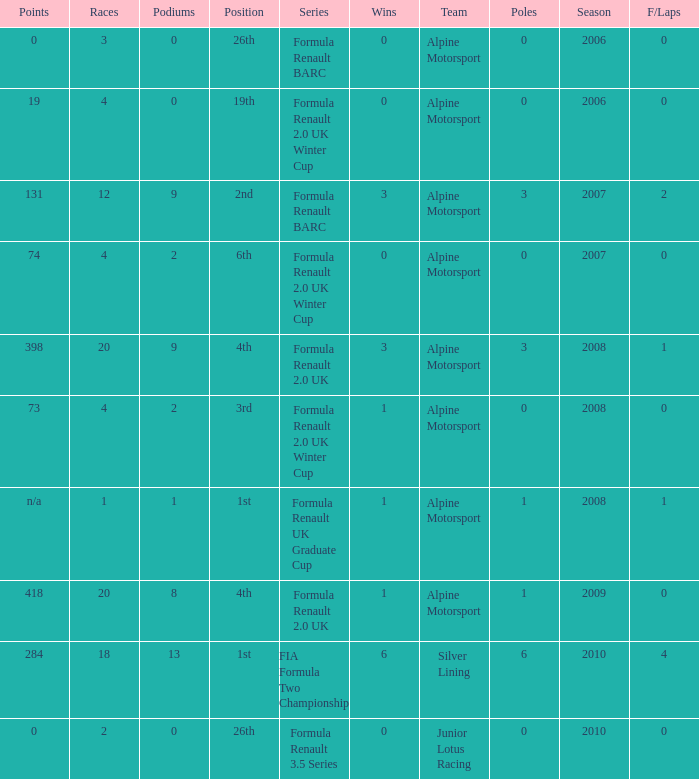How much were the f/laps if poles is higher than 1.0 during 2008? 1.0. 